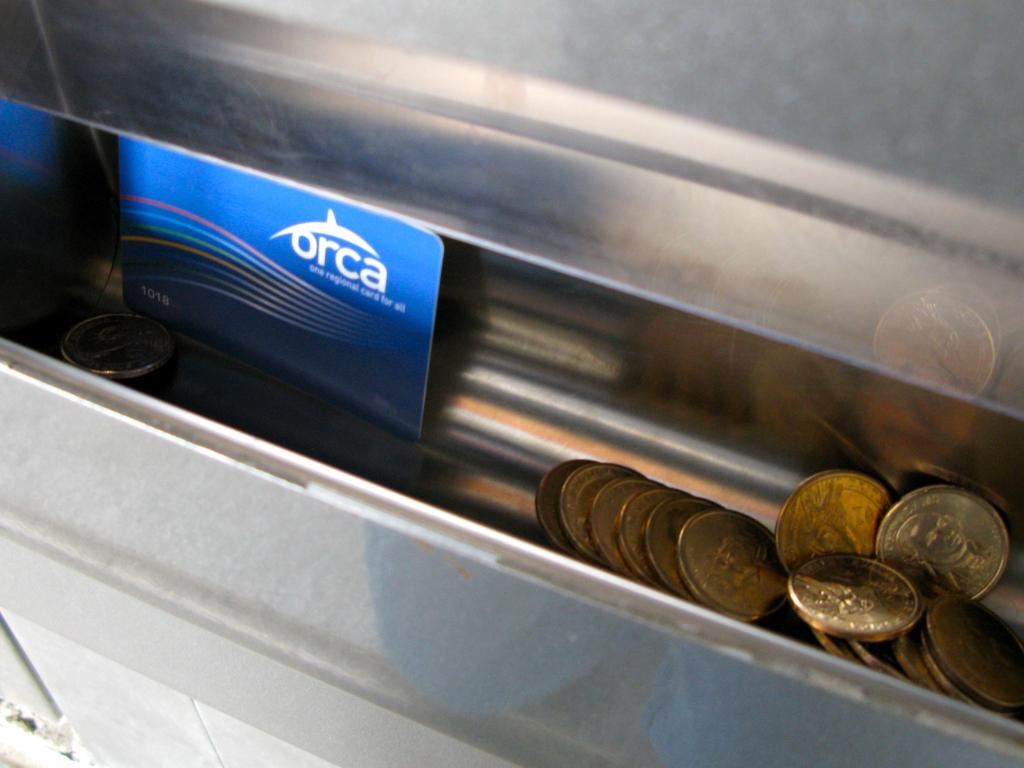Provide a one-sentence caption for the provided image. Some change and a card with the word "orca" on it are in a tray. 